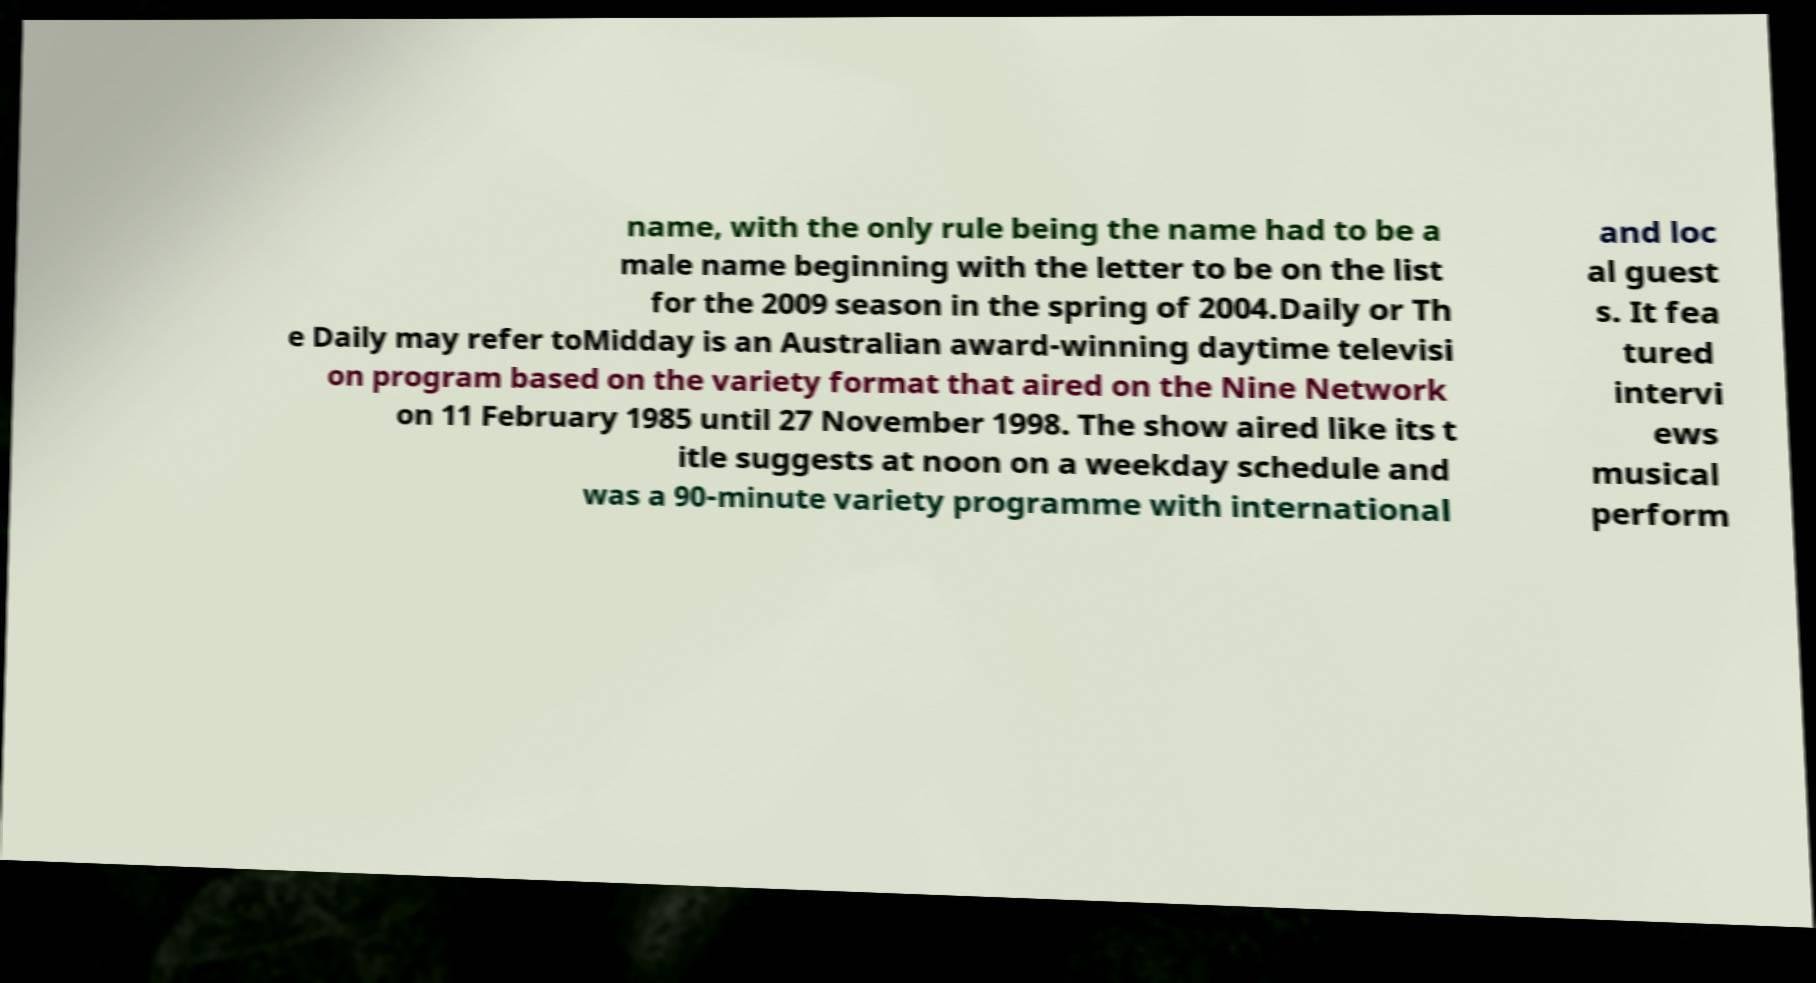There's text embedded in this image that I need extracted. Can you transcribe it verbatim? name, with the only rule being the name had to be a male name beginning with the letter to be on the list for the 2009 season in the spring of 2004.Daily or Th e Daily may refer toMidday is an Australian award-winning daytime televisi on program based on the variety format that aired on the Nine Network on 11 February 1985 until 27 November 1998. The show aired like its t itle suggests at noon on a weekday schedule and was a 90-minute variety programme with international and loc al guest s. It fea tured intervi ews musical perform 